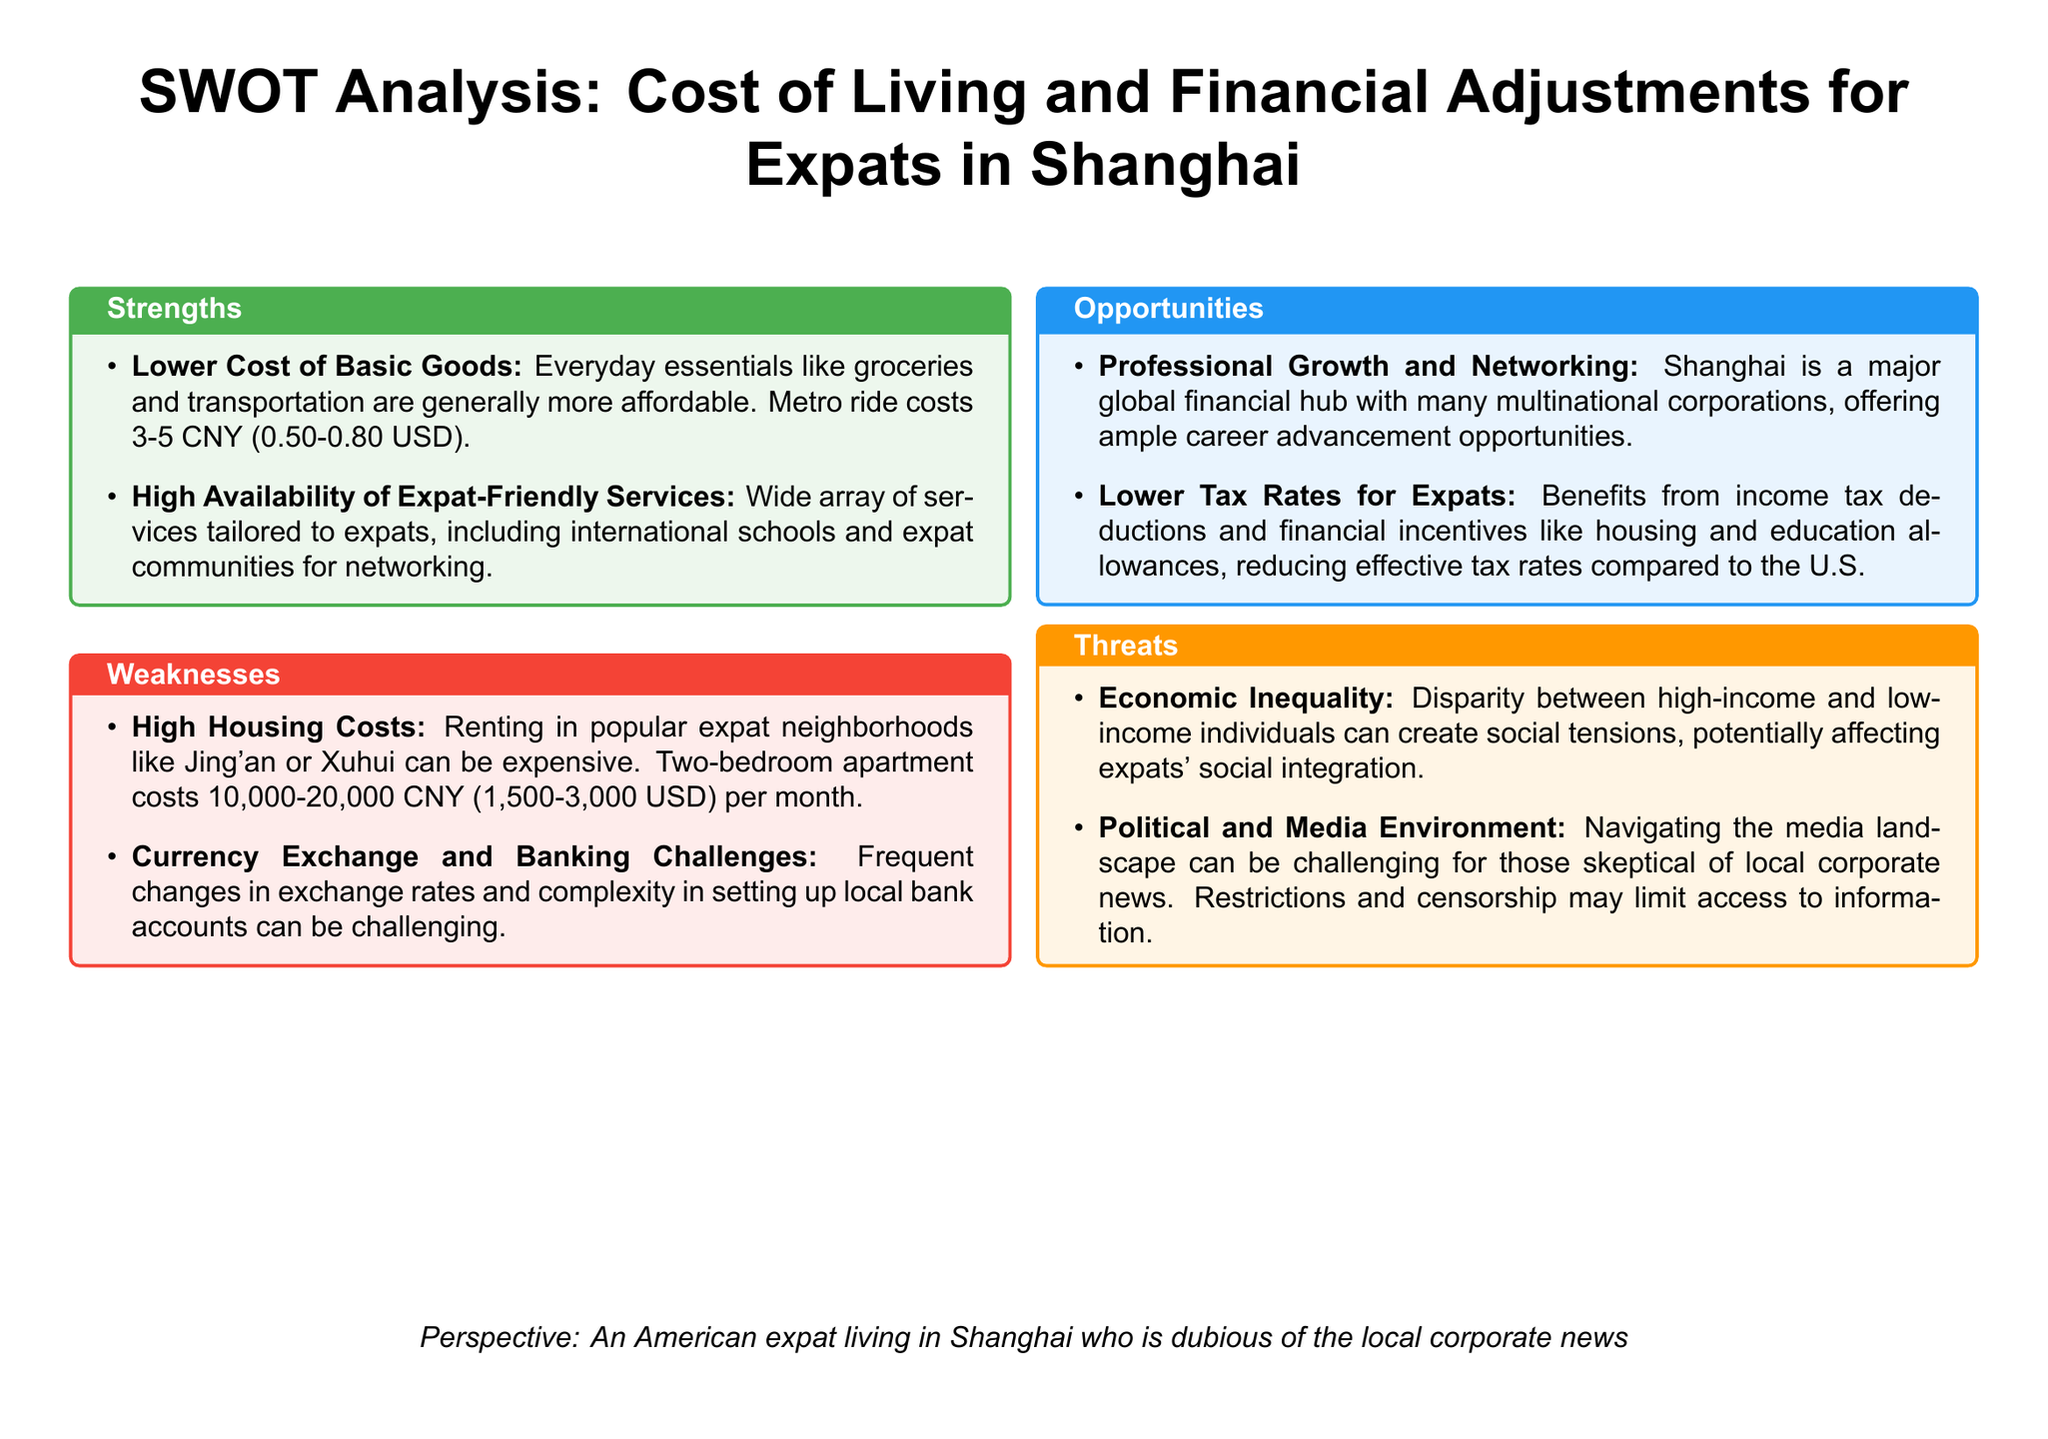what is the cost of a metro ride in Shanghai? The cost of a metro ride ranges from 3-5 CNY.
Answer: 3-5 CNY what is the monthly rent range for a two-bedroom apartment in expat neighborhoods? The monthly rent for a two-bedroom apartment in popular expat neighborhoods ranges from 10,000-20,000 CNY.
Answer: 10,000-20,000 CNY what is one strength mentioned about the cost of living for expats in Shanghai? One strength mentioned is the lower cost of basic goods like groceries and transportation.
Answer: Lower cost of basic goods what are two weaknesses related to financial adjustments for expats? The two weaknesses mentioned are high housing costs and currency exchange and banking challenges.
Answer: High housing costs; Currency exchange and banking challenges what is a professional opportunity for expats in Shanghai? A professional opportunity for expats is the chance for career advancement in a major global financial hub.
Answer: Career advancement in a major global financial hub what is a threat that could affect expats' social integration? Economic inequality can create social tensions and affect expats' social integration.
Answer: Economic inequality which area offers lower tax rates for expats? Lower tax rates for expats are beneficial due to income tax deductions and financial incentives.
Answer: Financial incentives what type of environment for media is mentioned as a threat? The political and media environment is mentioned as a challenge for those skeptical of local corporate news.
Answer: Political and media environment how does Shanghai's community support expats? Shanghai has a high availability of expat-friendly services, including international schools and expat communities.
Answer: Expat-friendly services 